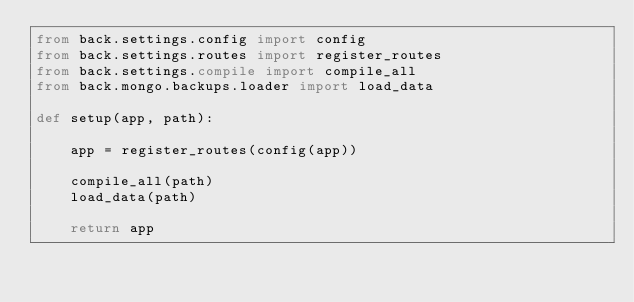Convert code to text. <code><loc_0><loc_0><loc_500><loc_500><_Python_>from back.settings.config import config
from back.settings.routes import register_routes
from back.settings.compile import compile_all
from back.mongo.backups.loader import load_data

def setup(app, path):

    app = register_routes(config(app))

    compile_all(path)
    load_data(path)

    return app
</code> 